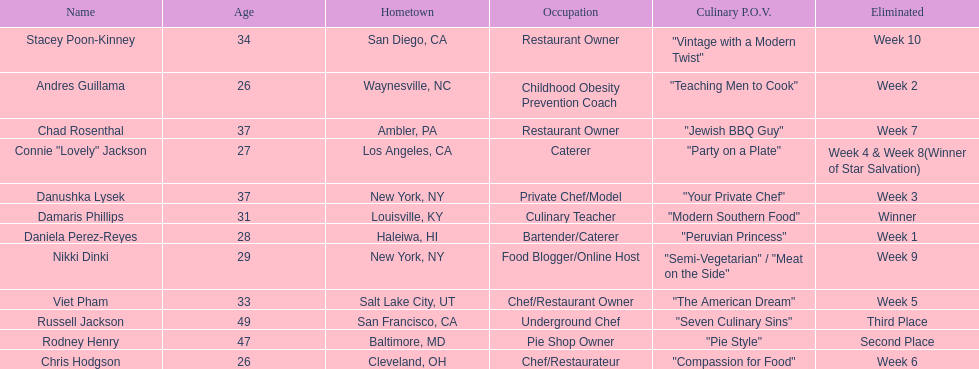Who was eliminated first, nikki dinki or viet pham? Viet Pham. 